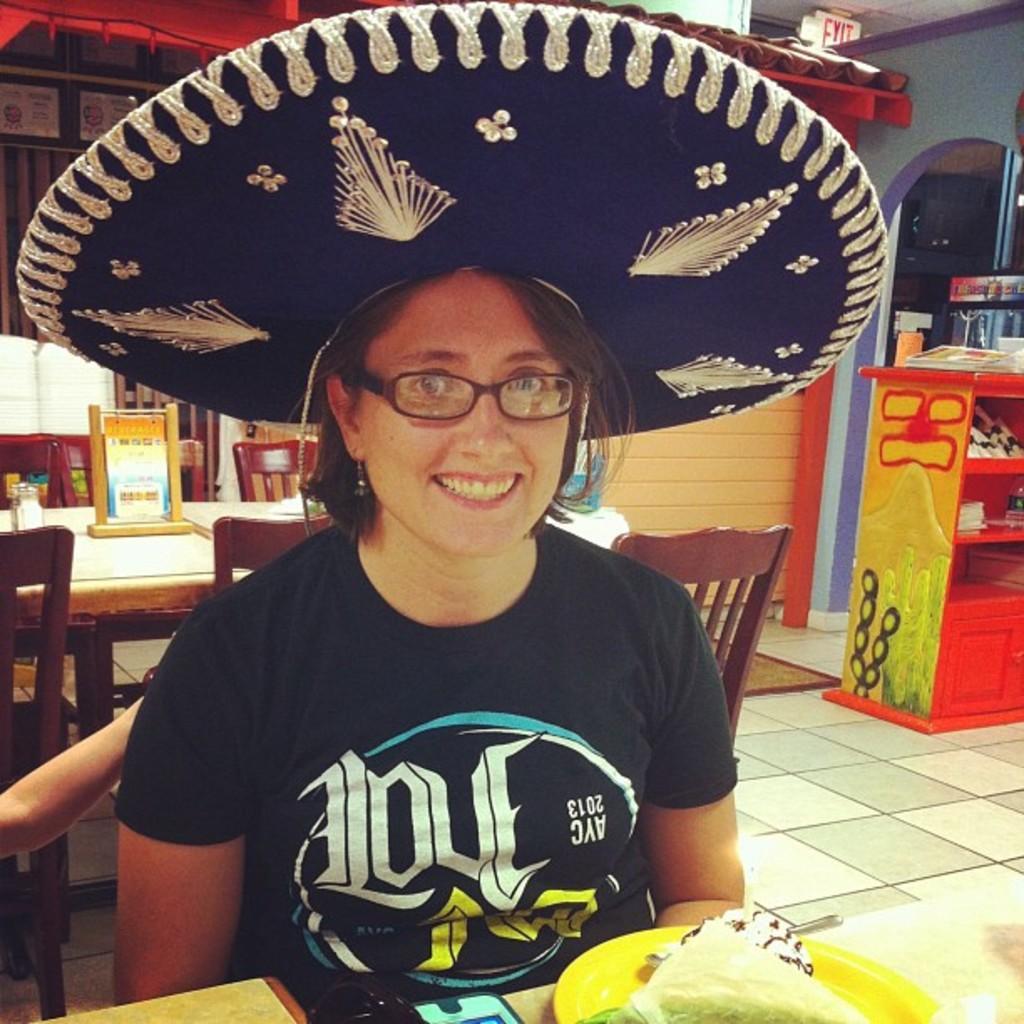In one or two sentences, can you explain what this image depicts? This picture is clicked inside. In the foreground there is a person wearing t-shirt, hat, smiling and sitting and we can see there are some items placed on the tables and we can see the wooden chairs, cabinets containing some items. In the background there is a wall and some other items. 